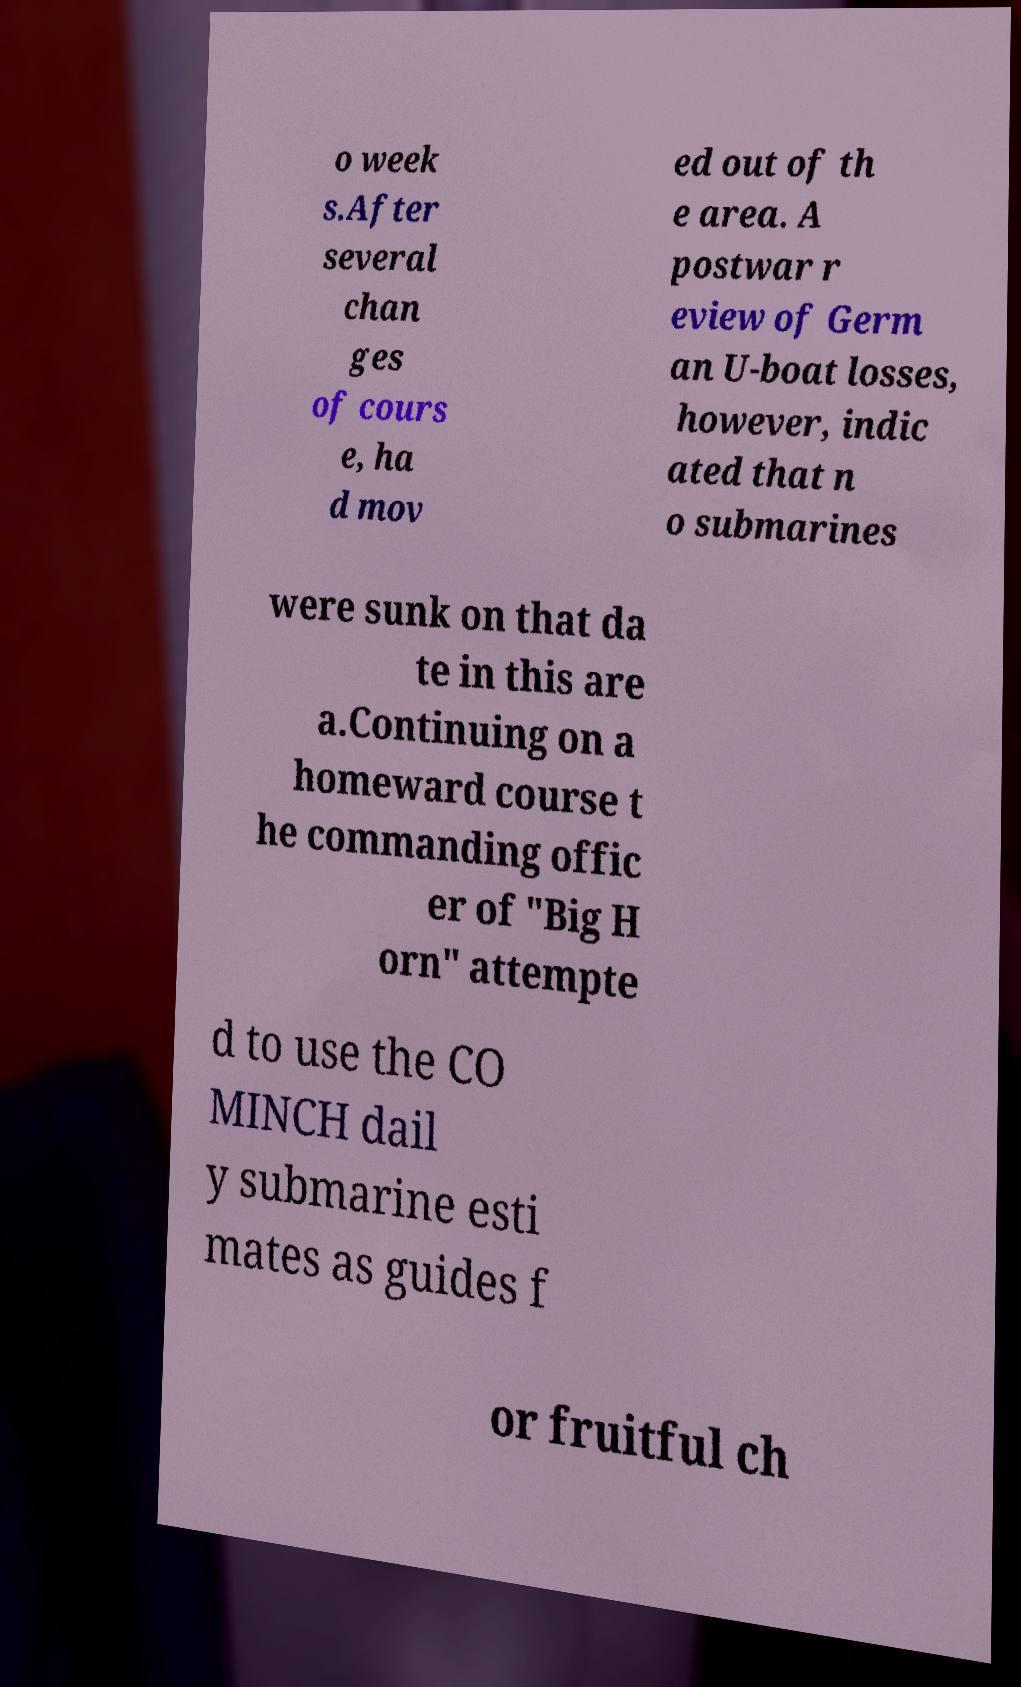Please identify and transcribe the text found in this image. o week s.After several chan ges of cours e, ha d mov ed out of th e area. A postwar r eview of Germ an U-boat losses, however, indic ated that n o submarines were sunk on that da te in this are a.Continuing on a homeward course t he commanding offic er of "Big H orn" attempte d to use the CO MINCH dail y submarine esti mates as guides f or fruitful ch 